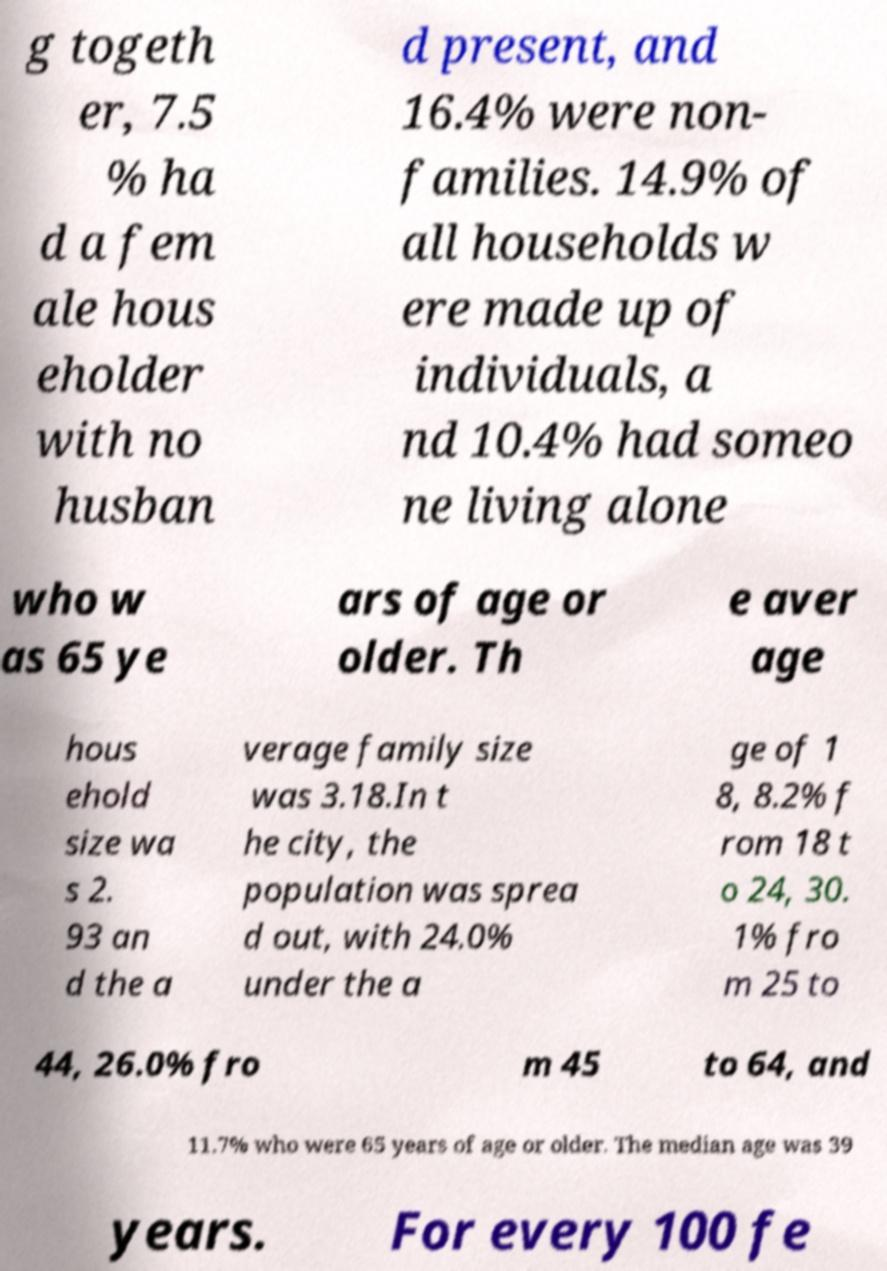Can you read and provide the text displayed in the image?This photo seems to have some interesting text. Can you extract and type it out for me? g togeth er, 7.5 % ha d a fem ale hous eholder with no husban d present, and 16.4% were non- families. 14.9% of all households w ere made up of individuals, a nd 10.4% had someo ne living alone who w as 65 ye ars of age or older. Th e aver age hous ehold size wa s 2. 93 an d the a verage family size was 3.18.In t he city, the population was sprea d out, with 24.0% under the a ge of 1 8, 8.2% f rom 18 t o 24, 30. 1% fro m 25 to 44, 26.0% fro m 45 to 64, and 11.7% who were 65 years of age or older. The median age was 39 years. For every 100 fe 